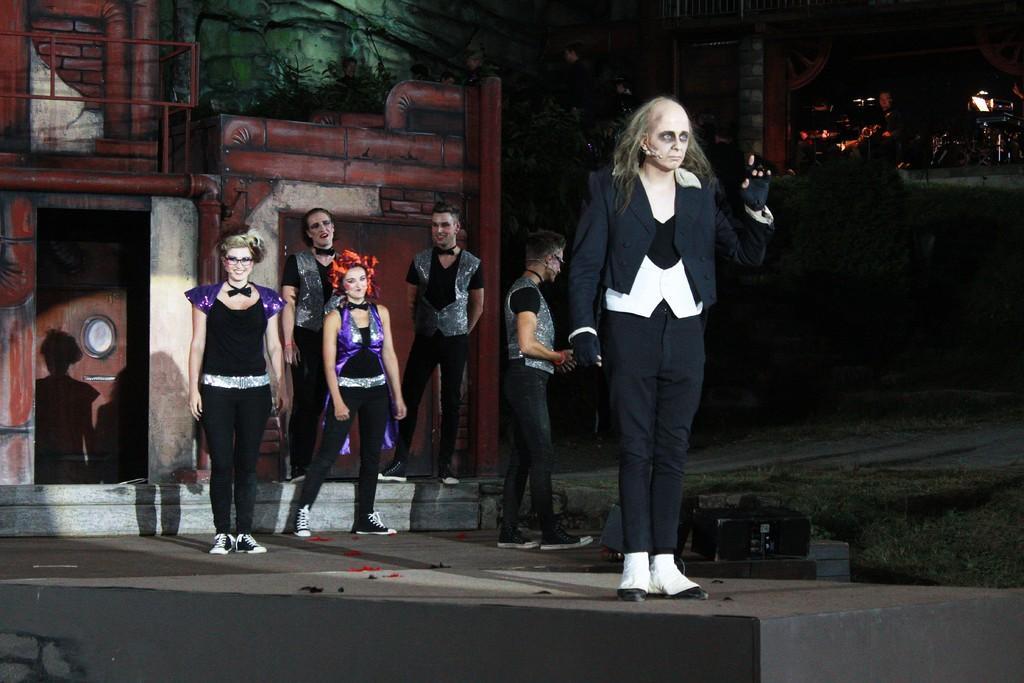Could you give a brief overview of what you see in this image? Here in this picture in the front we ca see a person standing on the stage with weird makeup on him and behind him also we can see a group of people standing over there and all of them are smiling and behind them we can see a set present over there. 